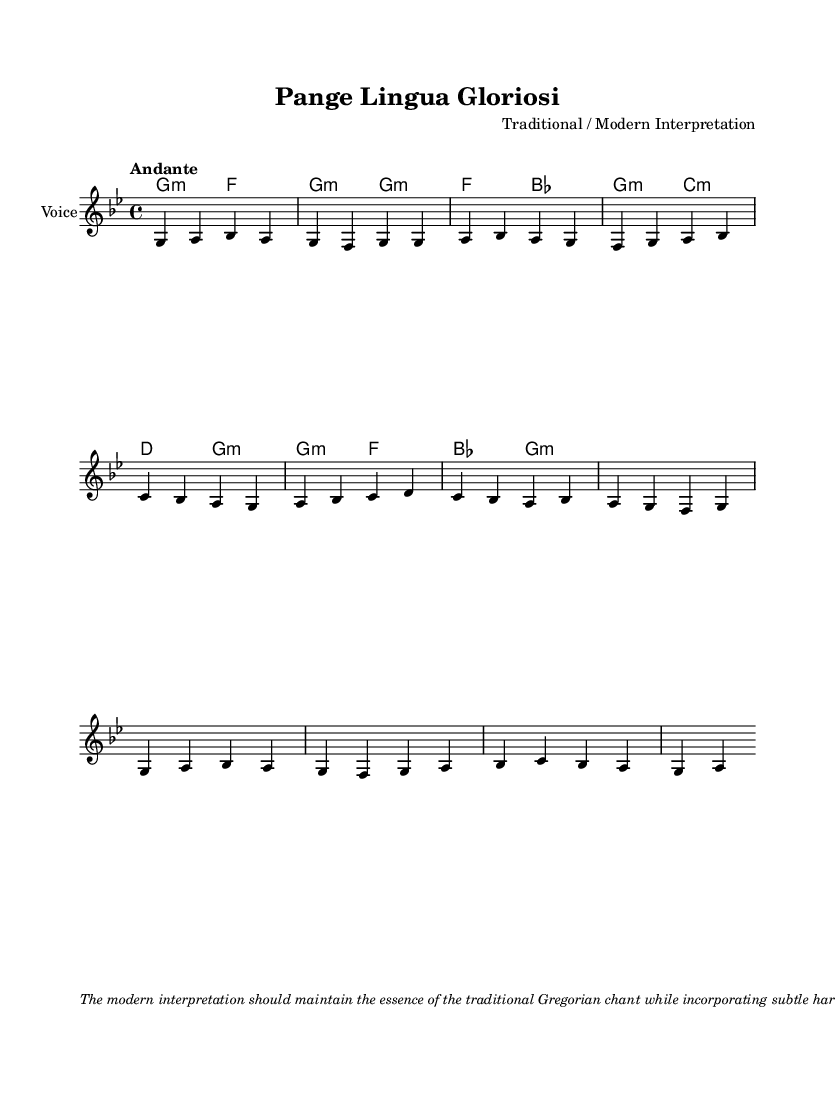What is the key signature of this music? The key signature is indicated at the beginning of the score, which shows two flats, thus corresponding to B-flat major or G minor.
Answer: G minor What is the time signature of this piece? The time signature is found at the beginning of the score, showing a "4/4" which indicates four beats per measure.
Answer: 4/4 What is the tempo marking for this chant? The tempo marking appears at the start of the score and states "Andante," which indicates a moderate walking pace.
Answer: Andante How many verses are presented in the melody? The melody section includes two verses as indicated in the notation, with the first and second verses both having distinct melodic lines.
Answer: 2 What type of harmonies are used in this Gregorian chant? The harmonies are indicated in a chord mode beneath the melody and include minor chords, reflective of the somber quality typical in Gregorian chant.
Answer: Minor How are the dynamics expressed in the modern interpretation? The dynamics are not explicitly indicated in the score, but the notes suggest a consistent volume with slight ritardandos at the end of each verse, enhancing the expressive quality.
Answer: Subtle dynamics What does the modern interpretation emphasize in the performance? The modern interpretation, based on the notes, emphasizes maintaining the essence of the traditional chant while integrating harmonious support, enhancing the overall sound.
Answer: Essence and harmonies 